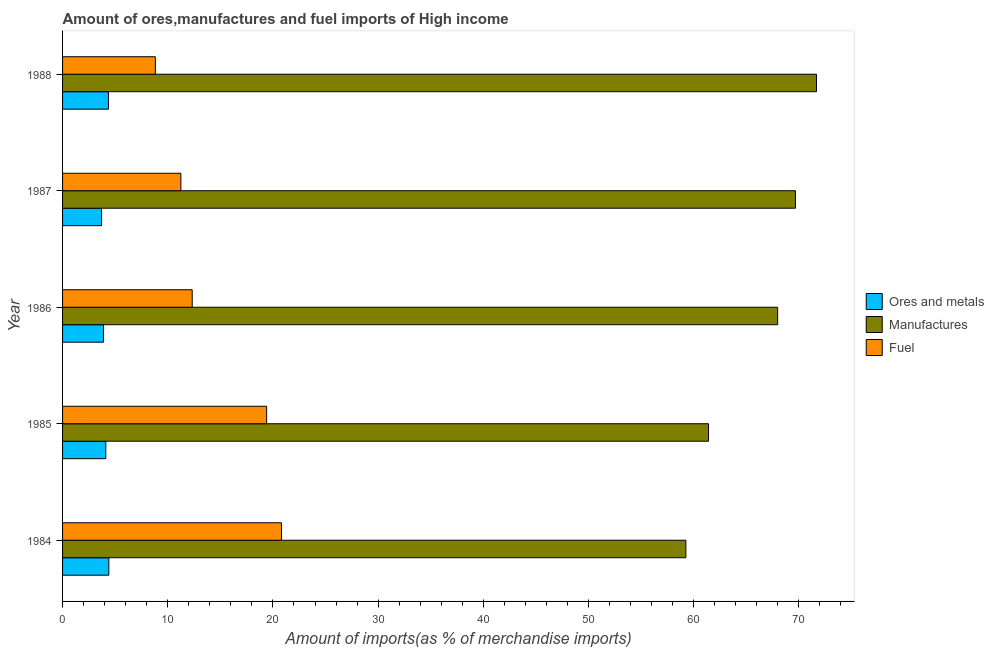How many groups of bars are there?
Your answer should be compact. 5. Are the number of bars per tick equal to the number of legend labels?
Give a very brief answer. Yes. Are the number of bars on each tick of the Y-axis equal?
Keep it short and to the point. Yes. How many bars are there on the 1st tick from the bottom?
Offer a very short reply. 3. What is the percentage of manufactures imports in 1985?
Provide a succinct answer. 61.41. Across all years, what is the maximum percentage of ores and metals imports?
Give a very brief answer. 4.4. Across all years, what is the minimum percentage of ores and metals imports?
Provide a succinct answer. 3.71. In which year was the percentage of ores and metals imports maximum?
Give a very brief answer. 1984. In which year was the percentage of fuel imports minimum?
Your response must be concise. 1988. What is the total percentage of manufactures imports in the graph?
Provide a short and direct response. 329.99. What is the difference between the percentage of fuel imports in 1985 and that in 1986?
Make the answer very short. 7.08. What is the difference between the percentage of manufactures imports in 1988 and the percentage of ores and metals imports in 1984?
Make the answer very short. 67.27. What is the average percentage of manufactures imports per year?
Provide a succinct answer. 66. In the year 1985, what is the difference between the percentage of manufactures imports and percentage of ores and metals imports?
Ensure brevity in your answer.  57.3. In how many years, is the percentage of fuel imports greater than 64 %?
Offer a terse response. 0. What is the ratio of the percentage of fuel imports in 1985 to that in 1987?
Offer a terse response. 1.73. Is the percentage of manufactures imports in 1986 less than that in 1988?
Offer a very short reply. Yes. What is the difference between the highest and the second highest percentage of manufactures imports?
Provide a short and direct response. 2. What is the difference between the highest and the lowest percentage of ores and metals imports?
Your answer should be very brief. 0.69. In how many years, is the percentage of fuel imports greater than the average percentage of fuel imports taken over all years?
Provide a succinct answer. 2. Is the sum of the percentage of fuel imports in 1986 and 1987 greater than the maximum percentage of manufactures imports across all years?
Ensure brevity in your answer.  No. What does the 2nd bar from the top in 1988 represents?
Make the answer very short. Manufactures. What does the 1st bar from the bottom in 1986 represents?
Your answer should be compact. Ores and metals. Is it the case that in every year, the sum of the percentage of ores and metals imports and percentage of manufactures imports is greater than the percentage of fuel imports?
Provide a short and direct response. Yes. How many bars are there?
Offer a terse response. 15. Are all the bars in the graph horizontal?
Offer a terse response. Yes. Does the graph contain grids?
Provide a short and direct response. No. What is the title of the graph?
Offer a very short reply. Amount of ores,manufactures and fuel imports of High income. Does "Tertiary education" appear as one of the legend labels in the graph?
Make the answer very short. No. What is the label or title of the X-axis?
Keep it short and to the point. Amount of imports(as % of merchandise imports). What is the Amount of imports(as % of merchandise imports) in Ores and metals in 1984?
Offer a very short reply. 4.4. What is the Amount of imports(as % of merchandise imports) of Manufactures in 1984?
Offer a terse response. 59.25. What is the Amount of imports(as % of merchandise imports) of Fuel in 1984?
Give a very brief answer. 20.81. What is the Amount of imports(as % of merchandise imports) of Ores and metals in 1985?
Keep it short and to the point. 4.11. What is the Amount of imports(as % of merchandise imports) of Manufactures in 1985?
Provide a short and direct response. 61.41. What is the Amount of imports(as % of merchandise imports) of Fuel in 1985?
Your response must be concise. 19.4. What is the Amount of imports(as % of merchandise imports) in Ores and metals in 1986?
Offer a very short reply. 3.89. What is the Amount of imports(as % of merchandise imports) in Manufactures in 1986?
Provide a succinct answer. 67.98. What is the Amount of imports(as % of merchandise imports) of Fuel in 1986?
Ensure brevity in your answer.  12.32. What is the Amount of imports(as % of merchandise imports) of Ores and metals in 1987?
Keep it short and to the point. 3.71. What is the Amount of imports(as % of merchandise imports) in Manufactures in 1987?
Ensure brevity in your answer.  69.67. What is the Amount of imports(as % of merchandise imports) of Fuel in 1987?
Give a very brief answer. 11.25. What is the Amount of imports(as % of merchandise imports) in Ores and metals in 1988?
Ensure brevity in your answer.  4.36. What is the Amount of imports(as % of merchandise imports) in Manufactures in 1988?
Your response must be concise. 71.67. What is the Amount of imports(as % of merchandise imports) in Fuel in 1988?
Your response must be concise. 8.82. Across all years, what is the maximum Amount of imports(as % of merchandise imports) in Ores and metals?
Your answer should be very brief. 4.4. Across all years, what is the maximum Amount of imports(as % of merchandise imports) of Manufactures?
Your response must be concise. 71.67. Across all years, what is the maximum Amount of imports(as % of merchandise imports) of Fuel?
Your answer should be compact. 20.81. Across all years, what is the minimum Amount of imports(as % of merchandise imports) of Ores and metals?
Ensure brevity in your answer.  3.71. Across all years, what is the minimum Amount of imports(as % of merchandise imports) of Manufactures?
Ensure brevity in your answer.  59.25. Across all years, what is the minimum Amount of imports(as % of merchandise imports) of Fuel?
Keep it short and to the point. 8.82. What is the total Amount of imports(as % of merchandise imports) of Ores and metals in the graph?
Your answer should be compact. 20.47. What is the total Amount of imports(as % of merchandise imports) in Manufactures in the graph?
Make the answer very short. 329.99. What is the total Amount of imports(as % of merchandise imports) in Fuel in the graph?
Your answer should be compact. 72.61. What is the difference between the Amount of imports(as % of merchandise imports) of Ores and metals in 1984 and that in 1985?
Offer a terse response. 0.29. What is the difference between the Amount of imports(as % of merchandise imports) in Manufactures in 1984 and that in 1985?
Provide a short and direct response. -2.15. What is the difference between the Amount of imports(as % of merchandise imports) of Fuel in 1984 and that in 1985?
Your answer should be very brief. 1.41. What is the difference between the Amount of imports(as % of merchandise imports) in Ores and metals in 1984 and that in 1986?
Make the answer very short. 0.51. What is the difference between the Amount of imports(as % of merchandise imports) in Manufactures in 1984 and that in 1986?
Provide a short and direct response. -8.73. What is the difference between the Amount of imports(as % of merchandise imports) in Fuel in 1984 and that in 1986?
Your answer should be very brief. 8.49. What is the difference between the Amount of imports(as % of merchandise imports) of Ores and metals in 1984 and that in 1987?
Provide a succinct answer. 0.69. What is the difference between the Amount of imports(as % of merchandise imports) of Manufactures in 1984 and that in 1987?
Your answer should be compact. -10.42. What is the difference between the Amount of imports(as % of merchandise imports) in Fuel in 1984 and that in 1987?
Your response must be concise. 9.56. What is the difference between the Amount of imports(as % of merchandise imports) of Ores and metals in 1984 and that in 1988?
Keep it short and to the point. 0.04. What is the difference between the Amount of imports(as % of merchandise imports) of Manufactures in 1984 and that in 1988?
Offer a very short reply. -12.42. What is the difference between the Amount of imports(as % of merchandise imports) in Fuel in 1984 and that in 1988?
Make the answer very short. 11.99. What is the difference between the Amount of imports(as % of merchandise imports) of Ores and metals in 1985 and that in 1986?
Keep it short and to the point. 0.22. What is the difference between the Amount of imports(as % of merchandise imports) of Manufactures in 1985 and that in 1986?
Your answer should be very brief. -6.57. What is the difference between the Amount of imports(as % of merchandise imports) in Fuel in 1985 and that in 1986?
Offer a terse response. 7.08. What is the difference between the Amount of imports(as % of merchandise imports) of Ores and metals in 1985 and that in 1987?
Offer a very short reply. 0.4. What is the difference between the Amount of imports(as % of merchandise imports) in Manufactures in 1985 and that in 1987?
Offer a very short reply. -8.26. What is the difference between the Amount of imports(as % of merchandise imports) in Fuel in 1985 and that in 1987?
Keep it short and to the point. 8.15. What is the difference between the Amount of imports(as % of merchandise imports) of Ores and metals in 1985 and that in 1988?
Give a very brief answer. -0.25. What is the difference between the Amount of imports(as % of merchandise imports) in Manufactures in 1985 and that in 1988?
Keep it short and to the point. -10.27. What is the difference between the Amount of imports(as % of merchandise imports) in Fuel in 1985 and that in 1988?
Provide a succinct answer. 10.58. What is the difference between the Amount of imports(as % of merchandise imports) of Ores and metals in 1986 and that in 1987?
Your answer should be compact. 0.18. What is the difference between the Amount of imports(as % of merchandise imports) of Manufactures in 1986 and that in 1987?
Ensure brevity in your answer.  -1.69. What is the difference between the Amount of imports(as % of merchandise imports) in Fuel in 1986 and that in 1987?
Make the answer very short. 1.08. What is the difference between the Amount of imports(as % of merchandise imports) of Ores and metals in 1986 and that in 1988?
Ensure brevity in your answer.  -0.47. What is the difference between the Amount of imports(as % of merchandise imports) in Manufactures in 1986 and that in 1988?
Your response must be concise. -3.69. What is the difference between the Amount of imports(as % of merchandise imports) in Fuel in 1986 and that in 1988?
Make the answer very short. 3.5. What is the difference between the Amount of imports(as % of merchandise imports) of Ores and metals in 1987 and that in 1988?
Provide a succinct answer. -0.65. What is the difference between the Amount of imports(as % of merchandise imports) in Manufactures in 1987 and that in 1988?
Your response must be concise. -2. What is the difference between the Amount of imports(as % of merchandise imports) in Fuel in 1987 and that in 1988?
Your answer should be very brief. 2.43. What is the difference between the Amount of imports(as % of merchandise imports) of Ores and metals in 1984 and the Amount of imports(as % of merchandise imports) of Manufactures in 1985?
Give a very brief answer. -57.01. What is the difference between the Amount of imports(as % of merchandise imports) of Ores and metals in 1984 and the Amount of imports(as % of merchandise imports) of Fuel in 1985?
Offer a terse response. -15. What is the difference between the Amount of imports(as % of merchandise imports) in Manufactures in 1984 and the Amount of imports(as % of merchandise imports) in Fuel in 1985?
Your answer should be very brief. 39.85. What is the difference between the Amount of imports(as % of merchandise imports) in Ores and metals in 1984 and the Amount of imports(as % of merchandise imports) in Manufactures in 1986?
Offer a very short reply. -63.58. What is the difference between the Amount of imports(as % of merchandise imports) of Ores and metals in 1984 and the Amount of imports(as % of merchandise imports) of Fuel in 1986?
Your response must be concise. -7.92. What is the difference between the Amount of imports(as % of merchandise imports) in Manufactures in 1984 and the Amount of imports(as % of merchandise imports) in Fuel in 1986?
Your answer should be compact. 46.93. What is the difference between the Amount of imports(as % of merchandise imports) of Ores and metals in 1984 and the Amount of imports(as % of merchandise imports) of Manufactures in 1987?
Your response must be concise. -65.27. What is the difference between the Amount of imports(as % of merchandise imports) of Ores and metals in 1984 and the Amount of imports(as % of merchandise imports) of Fuel in 1987?
Your response must be concise. -6.85. What is the difference between the Amount of imports(as % of merchandise imports) in Manufactures in 1984 and the Amount of imports(as % of merchandise imports) in Fuel in 1987?
Offer a terse response. 48.01. What is the difference between the Amount of imports(as % of merchandise imports) in Ores and metals in 1984 and the Amount of imports(as % of merchandise imports) in Manufactures in 1988?
Give a very brief answer. -67.27. What is the difference between the Amount of imports(as % of merchandise imports) of Ores and metals in 1984 and the Amount of imports(as % of merchandise imports) of Fuel in 1988?
Keep it short and to the point. -4.42. What is the difference between the Amount of imports(as % of merchandise imports) in Manufactures in 1984 and the Amount of imports(as % of merchandise imports) in Fuel in 1988?
Offer a very short reply. 50.43. What is the difference between the Amount of imports(as % of merchandise imports) of Ores and metals in 1985 and the Amount of imports(as % of merchandise imports) of Manufactures in 1986?
Your answer should be compact. -63.87. What is the difference between the Amount of imports(as % of merchandise imports) of Ores and metals in 1985 and the Amount of imports(as % of merchandise imports) of Fuel in 1986?
Your response must be concise. -8.21. What is the difference between the Amount of imports(as % of merchandise imports) of Manufactures in 1985 and the Amount of imports(as % of merchandise imports) of Fuel in 1986?
Offer a terse response. 49.08. What is the difference between the Amount of imports(as % of merchandise imports) in Ores and metals in 1985 and the Amount of imports(as % of merchandise imports) in Manufactures in 1987?
Give a very brief answer. -65.56. What is the difference between the Amount of imports(as % of merchandise imports) in Ores and metals in 1985 and the Amount of imports(as % of merchandise imports) in Fuel in 1987?
Ensure brevity in your answer.  -7.14. What is the difference between the Amount of imports(as % of merchandise imports) in Manufactures in 1985 and the Amount of imports(as % of merchandise imports) in Fuel in 1987?
Ensure brevity in your answer.  50.16. What is the difference between the Amount of imports(as % of merchandise imports) of Ores and metals in 1985 and the Amount of imports(as % of merchandise imports) of Manufactures in 1988?
Make the answer very short. -67.56. What is the difference between the Amount of imports(as % of merchandise imports) of Ores and metals in 1985 and the Amount of imports(as % of merchandise imports) of Fuel in 1988?
Give a very brief answer. -4.71. What is the difference between the Amount of imports(as % of merchandise imports) of Manufactures in 1985 and the Amount of imports(as % of merchandise imports) of Fuel in 1988?
Offer a very short reply. 52.59. What is the difference between the Amount of imports(as % of merchandise imports) of Ores and metals in 1986 and the Amount of imports(as % of merchandise imports) of Manufactures in 1987?
Offer a very short reply. -65.78. What is the difference between the Amount of imports(as % of merchandise imports) in Ores and metals in 1986 and the Amount of imports(as % of merchandise imports) in Fuel in 1987?
Keep it short and to the point. -7.36. What is the difference between the Amount of imports(as % of merchandise imports) of Manufactures in 1986 and the Amount of imports(as % of merchandise imports) of Fuel in 1987?
Make the answer very short. 56.73. What is the difference between the Amount of imports(as % of merchandise imports) in Ores and metals in 1986 and the Amount of imports(as % of merchandise imports) in Manufactures in 1988?
Your answer should be very brief. -67.79. What is the difference between the Amount of imports(as % of merchandise imports) in Ores and metals in 1986 and the Amount of imports(as % of merchandise imports) in Fuel in 1988?
Your answer should be compact. -4.93. What is the difference between the Amount of imports(as % of merchandise imports) of Manufactures in 1986 and the Amount of imports(as % of merchandise imports) of Fuel in 1988?
Make the answer very short. 59.16. What is the difference between the Amount of imports(as % of merchandise imports) in Ores and metals in 1987 and the Amount of imports(as % of merchandise imports) in Manufactures in 1988?
Your answer should be very brief. -67.97. What is the difference between the Amount of imports(as % of merchandise imports) of Ores and metals in 1987 and the Amount of imports(as % of merchandise imports) of Fuel in 1988?
Your answer should be compact. -5.11. What is the difference between the Amount of imports(as % of merchandise imports) in Manufactures in 1987 and the Amount of imports(as % of merchandise imports) in Fuel in 1988?
Ensure brevity in your answer.  60.85. What is the average Amount of imports(as % of merchandise imports) of Ores and metals per year?
Ensure brevity in your answer.  4.09. What is the average Amount of imports(as % of merchandise imports) of Manufactures per year?
Your answer should be compact. 66. What is the average Amount of imports(as % of merchandise imports) in Fuel per year?
Offer a terse response. 14.52. In the year 1984, what is the difference between the Amount of imports(as % of merchandise imports) in Ores and metals and Amount of imports(as % of merchandise imports) in Manufactures?
Your response must be concise. -54.85. In the year 1984, what is the difference between the Amount of imports(as % of merchandise imports) of Ores and metals and Amount of imports(as % of merchandise imports) of Fuel?
Make the answer very short. -16.41. In the year 1984, what is the difference between the Amount of imports(as % of merchandise imports) in Manufactures and Amount of imports(as % of merchandise imports) in Fuel?
Your answer should be very brief. 38.44. In the year 1985, what is the difference between the Amount of imports(as % of merchandise imports) in Ores and metals and Amount of imports(as % of merchandise imports) in Manufactures?
Provide a succinct answer. -57.3. In the year 1985, what is the difference between the Amount of imports(as % of merchandise imports) in Ores and metals and Amount of imports(as % of merchandise imports) in Fuel?
Keep it short and to the point. -15.29. In the year 1985, what is the difference between the Amount of imports(as % of merchandise imports) of Manufactures and Amount of imports(as % of merchandise imports) of Fuel?
Offer a terse response. 42.01. In the year 1986, what is the difference between the Amount of imports(as % of merchandise imports) of Ores and metals and Amount of imports(as % of merchandise imports) of Manufactures?
Your answer should be very brief. -64.09. In the year 1986, what is the difference between the Amount of imports(as % of merchandise imports) of Ores and metals and Amount of imports(as % of merchandise imports) of Fuel?
Your answer should be very brief. -8.44. In the year 1986, what is the difference between the Amount of imports(as % of merchandise imports) in Manufactures and Amount of imports(as % of merchandise imports) in Fuel?
Provide a short and direct response. 55.66. In the year 1987, what is the difference between the Amount of imports(as % of merchandise imports) of Ores and metals and Amount of imports(as % of merchandise imports) of Manufactures?
Give a very brief answer. -65.96. In the year 1987, what is the difference between the Amount of imports(as % of merchandise imports) of Ores and metals and Amount of imports(as % of merchandise imports) of Fuel?
Keep it short and to the point. -7.54. In the year 1987, what is the difference between the Amount of imports(as % of merchandise imports) in Manufactures and Amount of imports(as % of merchandise imports) in Fuel?
Ensure brevity in your answer.  58.42. In the year 1988, what is the difference between the Amount of imports(as % of merchandise imports) in Ores and metals and Amount of imports(as % of merchandise imports) in Manufactures?
Make the answer very short. -67.31. In the year 1988, what is the difference between the Amount of imports(as % of merchandise imports) in Ores and metals and Amount of imports(as % of merchandise imports) in Fuel?
Your answer should be very brief. -4.46. In the year 1988, what is the difference between the Amount of imports(as % of merchandise imports) in Manufactures and Amount of imports(as % of merchandise imports) in Fuel?
Your response must be concise. 62.85. What is the ratio of the Amount of imports(as % of merchandise imports) of Ores and metals in 1984 to that in 1985?
Give a very brief answer. 1.07. What is the ratio of the Amount of imports(as % of merchandise imports) in Manufactures in 1984 to that in 1985?
Make the answer very short. 0.96. What is the ratio of the Amount of imports(as % of merchandise imports) in Fuel in 1984 to that in 1985?
Offer a terse response. 1.07. What is the ratio of the Amount of imports(as % of merchandise imports) of Ores and metals in 1984 to that in 1986?
Offer a very short reply. 1.13. What is the ratio of the Amount of imports(as % of merchandise imports) of Manufactures in 1984 to that in 1986?
Offer a terse response. 0.87. What is the ratio of the Amount of imports(as % of merchandise imports) in Fuel in 1984 to that in 1986?
Provide a short and direct response. 1.69. What is the ratio of the Amount of imports(as % of merchandise imports) of Ores and metals in 1984 to that in 1987?
Make the answer very short. 1.19. What is the ratio of the Amount of imports(as % of merchandise imports) in Manufactures in 1984 to that in 1987?
Your response must be concise. 0.85. What is the ratio of the Amount of imports(as % of merchandise imports) in Fuel in 1984 to that in 1987?
Ensure brevity in your answer.  1.85. What is the ratio of the Amount of imports(as % of merchandise imports) in Ores and metals in 1984 to that in 1988?
Offer a terse response. 1.01. What is the ratio of the Amount of imports(as % of merchandise imports) of Manufactures in 1984 to that in 1988?
Give a very brief answer. 0.83. What is the ratio of the Amount of imports(as % of merchandise imports) in Fuel in 1984 to that in 1988?
Provide a succinct answer. 2.36. What is the ratio of the Amount of imports(as % of merchandise imports) in Ores and metals in 1985 to that in 1986?
Provide a succinct answer. 1.06. What is the ratio of the Amount of imports(as % of merchandise imports) of Manufactures in 1985 to that in 1986?
Ensure brevity in your answer.  0.9. What is the ratio of the Amount of imports(as % of merchandise imports) of Fuel in 1985 to that in 1986?
Make the answer very short. 1.57. What is the ratio of the Amount of imports(as % of merchandise imports) in Ores and metals in 1985 to that in 1987?
Your response must be concise. 1.11. What is the ratio of the Amount of imports(as % of merchandise imports) of Manufactures in 1985 to that in 1987?
Make the answer very short. 0.88. What is the ratio of the Amount of imports(as % of merchandise imports) of Fuel in 1985 to that in 1987?
Your answer should be very brief. 1.73. What is the ratio of the Amount of imports(as % of merchandise imports) in Ores and metals in 1985 to that in 1988?
Your answer should be very brief. 0.94. What is the ratio of the Amount of imports(as % of merchandise imports) of Manufactures in 1985 to that in 1988?
Give a very brief answer. 0.86. What is the ratio of the Amount of imports(as % of merchandise imports) of Fuel in 1985 to that in 1988?
Provide a short and direct response. 2.2. What is the ratio of the Amount of imports(as % of merchandise imports) of Ores and metals in 1986 to that in 1987?
Offer a very short reply. 1.05. What is the ratio of the Amount of imports(as % of merchandise imports) in Manufactures in 1986 to that in 1987?
Make the answer very short. 0.98. What is the ratio of the Amount of imports(as % of merchandise imports) of Fuel in 1986 to that in 1987?
Provide a short and direct response. 1.1. What is the ratio of the Amount of imports(as % of merchandise imports) of Ores and metals in 1986 to that in 1988?
Make the answer very short. 0.89. What is the ratio of the Amount of imports(as % of merchandise imports) in Manufactures in 1986 to that in 1988?
Keep it short and to the point. 0.95. What is the ratio of the Amount of imports(as % of merchandise imports) of Fuel in 1986 to that in 1988?
Your answer should be compact. 1.4. What is the ratio of the Amount of imports(as % of merchandise imports) in Fuel in 1987 to that in 1988?
Provide a succinct answer. 1.28. What is the difference between the highest and the second highest Amount of imports(as % of merchandise imports) of Ores and metals?
Provide a short and direct response. 0.04. What is the difference between the highest and the second highest Amount of imports(as % of merchandise imports) of Manufactures?
Provide a succinct answer. 2. What is the difference between the highest and the second highest Amount of imports(as % of merchandise imports) of Fuel?
Your response must be concise. 1.41. What is the difference between the highest and the lowest Amount of imports(as % of merchandise imports) of Ores and metals?
Provide a short and direct response. 0.69. What is the difference between the highest and the lowest Amount of imports(as % of merchandise imports) in Manufactures?
Provide a short and direct response. 12.42. What is the difference between the highest and the lowest Amount of imports(as % of merchandise imports) in Fuel?
Make the answer very short. 11.99. 